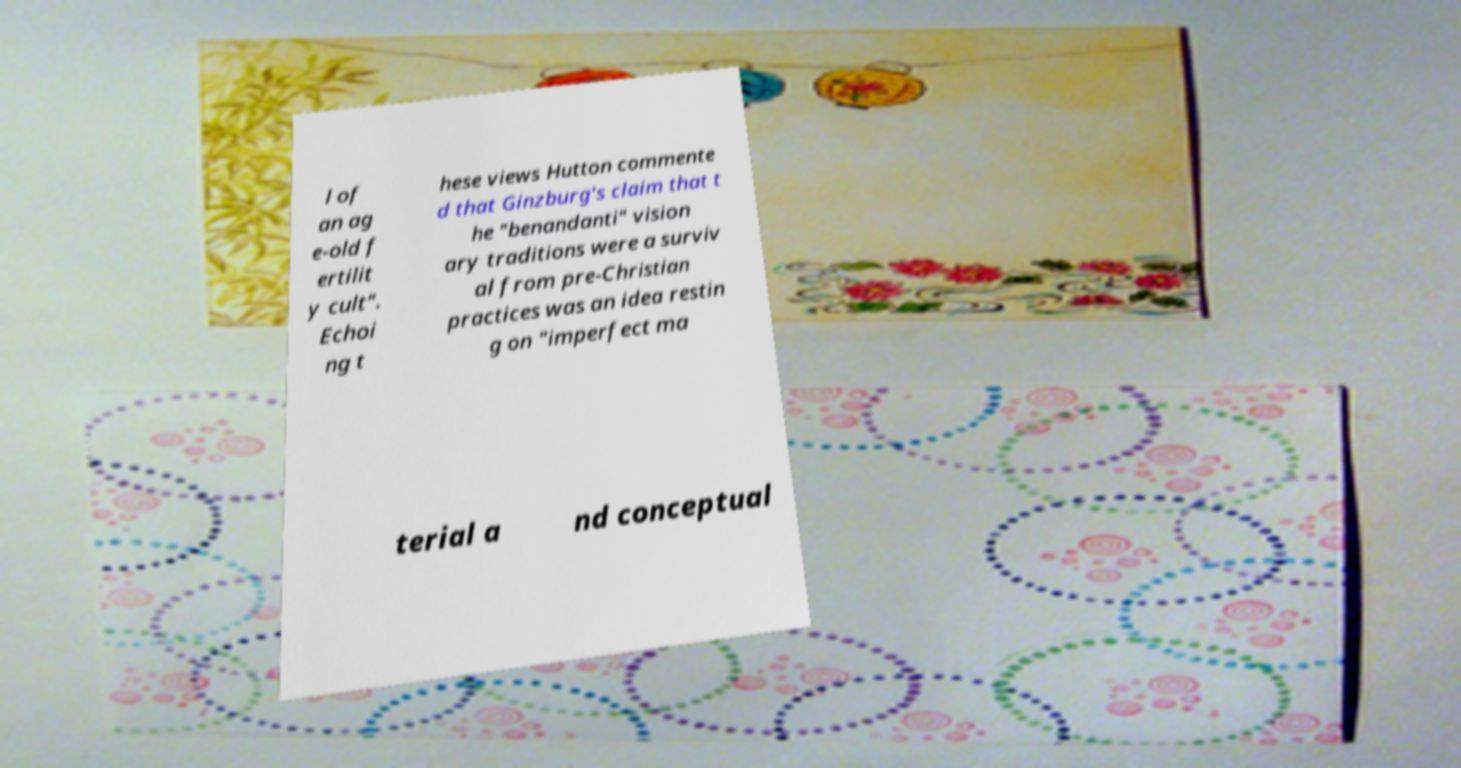There's text embedded in this image that I need extracted. Can you transcribe it verbatim? l of an ag e-old f ertilit y cult". Echoi ng t hese views Hutton commente d that Ginzburg's claim that t he "benandanti" vision ary traditions were a surviv al from pre-Christian practices was an idea restin g on "imperfect ma terial a nd conceptual 